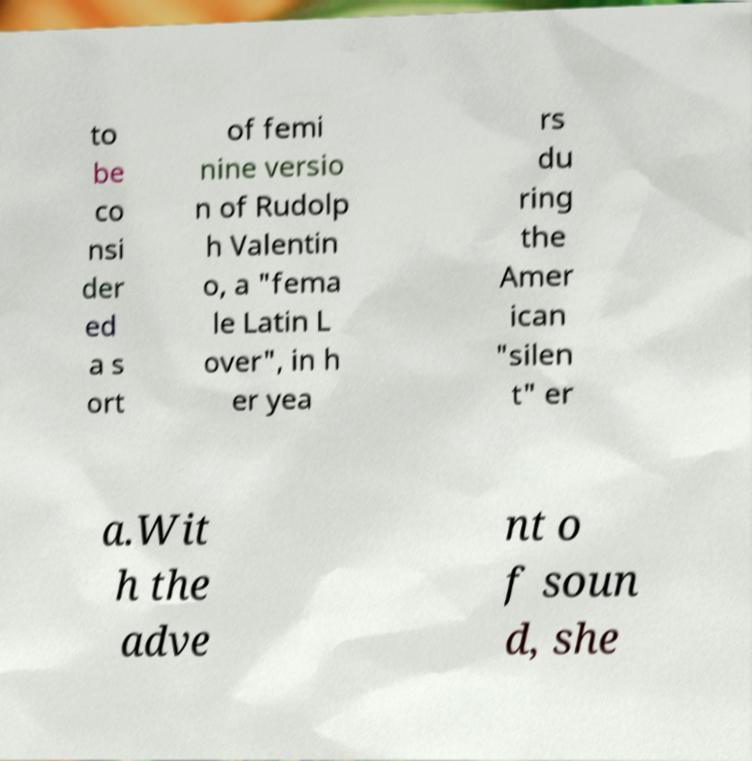What messages or text are displayed in this image? I need them in a readable, typed format. to be co nsi der ed a s ort of femi nine versio n of Rudolp h Valentin o, a "fema le Latin L over", in h er yea rs du ring the Amer ican "silen t" er a.Wit h the adve nt o f soun d, she 